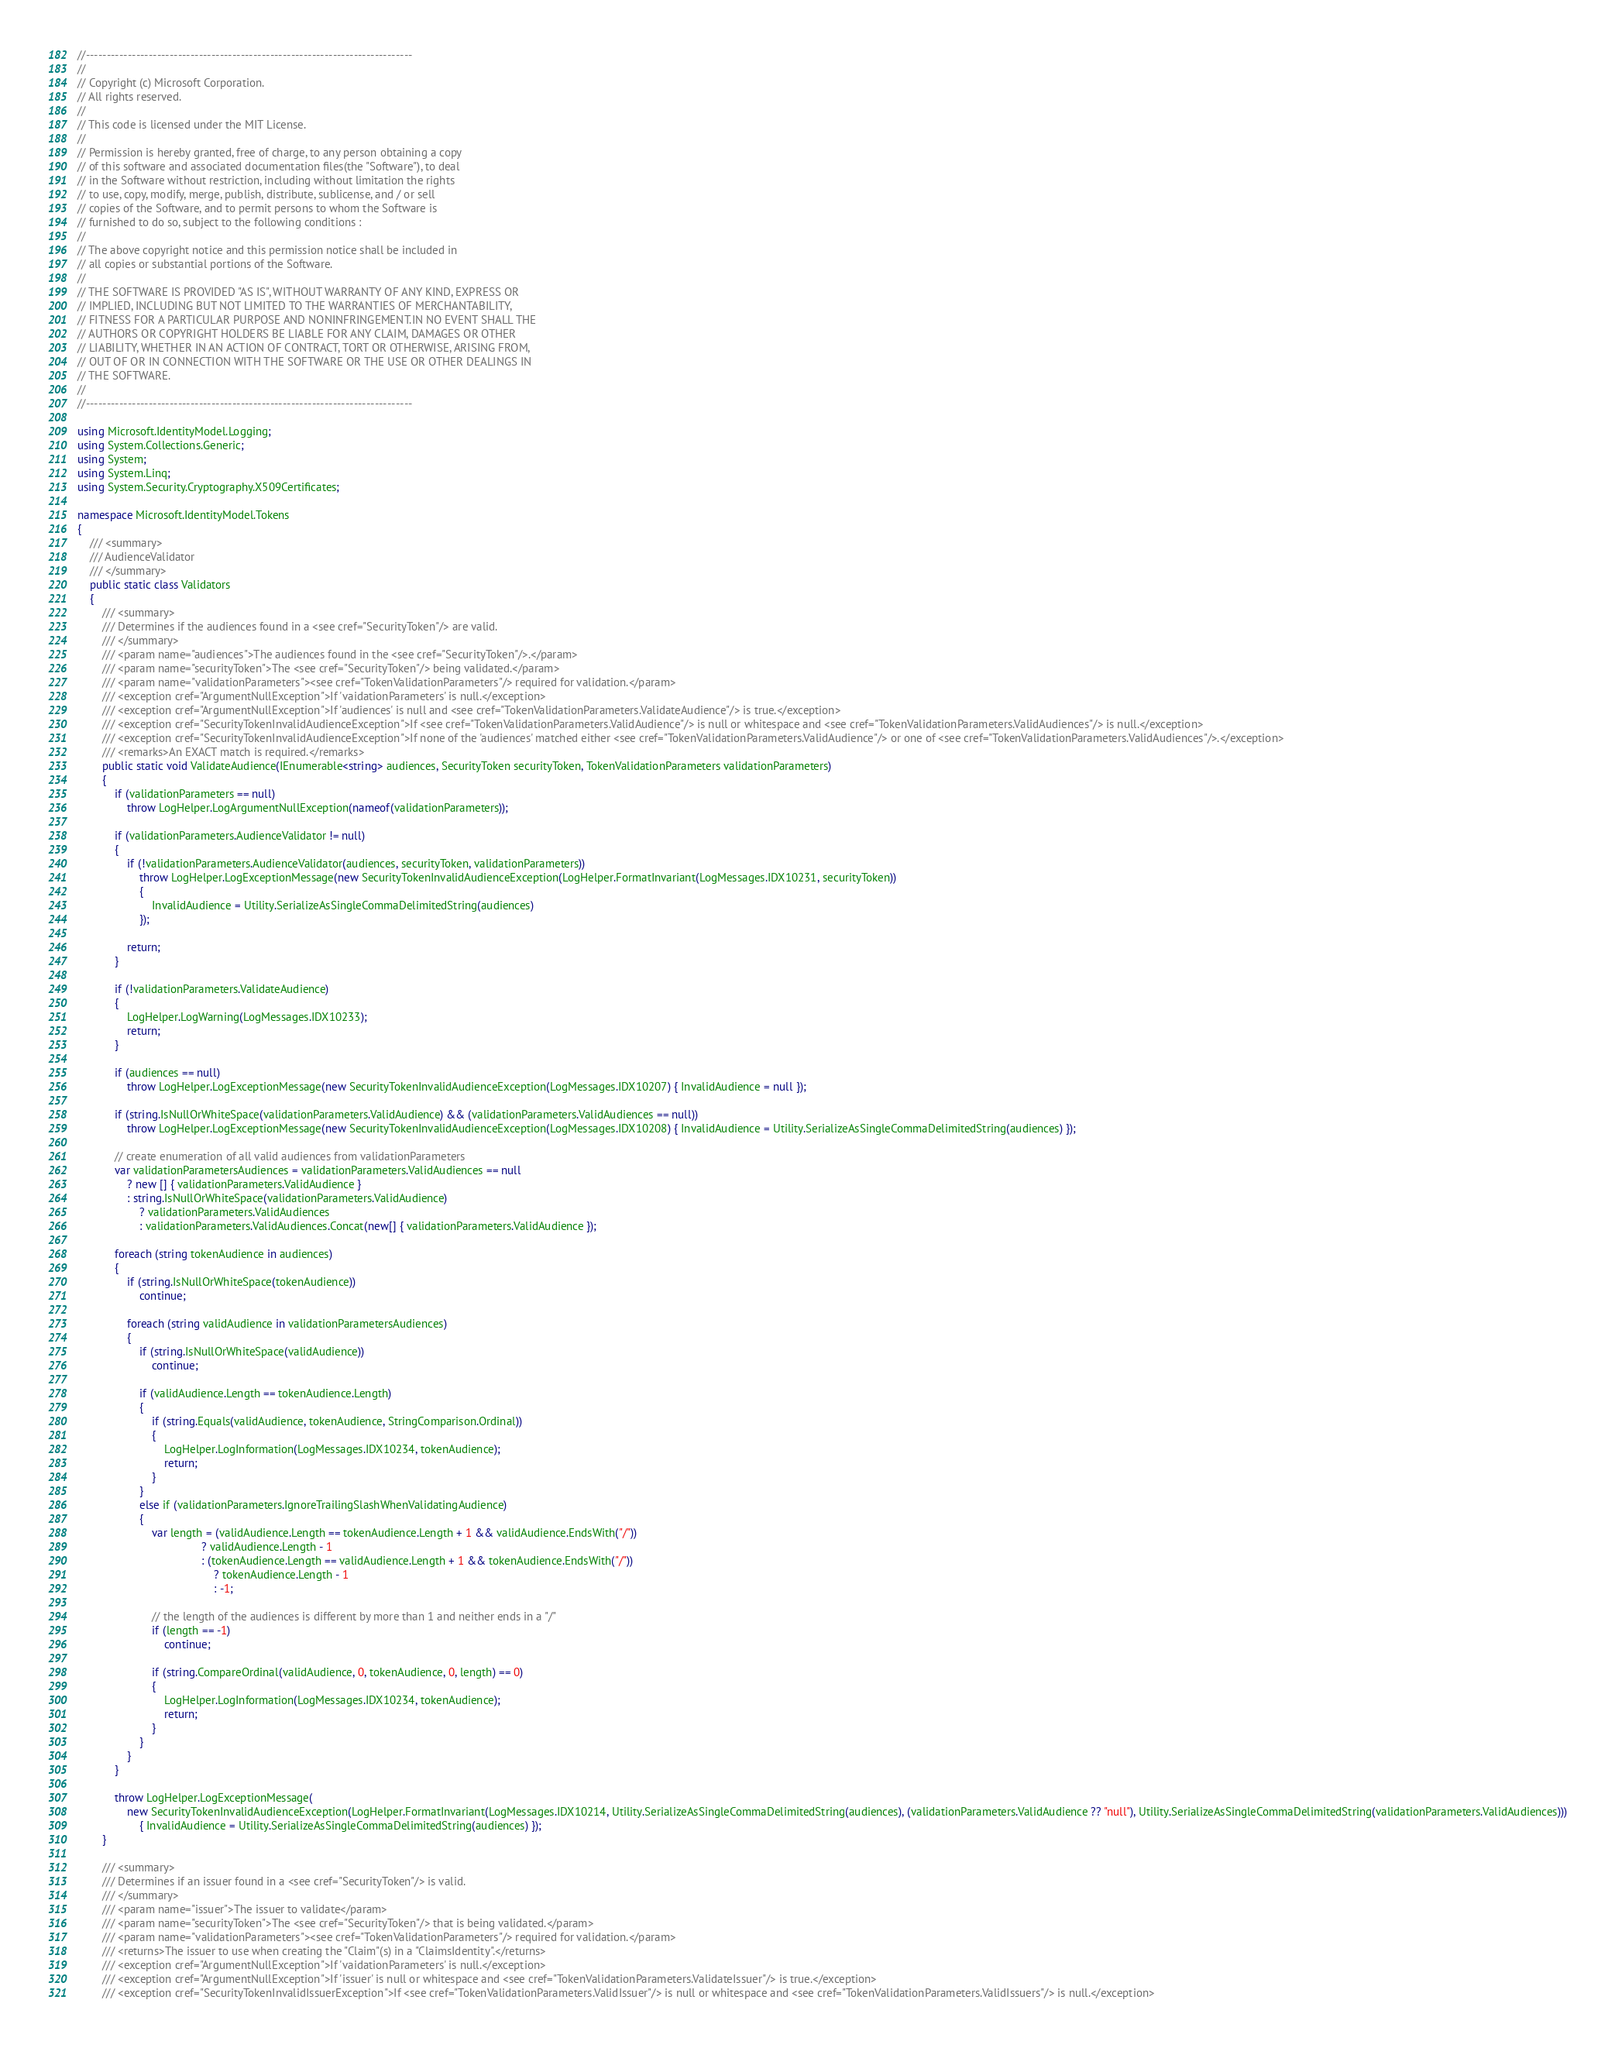<code> <loc_0><loc_0><loc_500><loc_500><_C#_>//------------------------------------------------------------------------------
//
// Copyright (c) Microsoft Corporation.
// All rights reserved.
//
// This code is licensed under the MIT License.
//
// Permission is hereby granted, free of charge, to any person obtaining a copy
// of this software and associated documentation files(the "Software"), to deal
// in the Software without restriction, including without limitation the rights
// to use, copy, modify, merge, publish, distribute, sublicense, and / or sell
// copies of the Software, and to permit persons to whom the Software is
// furnished to do so, subject to the following conditions :
//
// The above copyright notice and this permission notice shall be included in
// all copies or substantial portions of the Software.
//
// THE SOFTWARE IS PROVIDED "AS IS", WITHOUT WARRANTY OF ANY KIND, EXPRESS OR
// IMPLIED, INCLUDING BUT NOT LIMITED TO THE WARRANTIES OF MERCHANTABILITY,
// FITNESS FOR A PARTICULAR PURPOSE AND NONINFRINGEMENT.IN NO EVENT SHALL THE
// AUTHORS OR COPYRIGHT HOLDERS BE LIABLE FOR ANY CLAIM, DAMAGES OR OTHER
// LIABILITY, WHETHER IN AN ACTION OF CONTRACT, TORT OR OTHERWISE, ARISING FROM,
// OUT OF OR IN CONNECTION WITH THE SOFTWARE OR THE USE OR OTHER DEALINGS IN
// THE SOFTWARE.
//
//------------------------------------------------------------------------------

using Microsoft.IdentityModel.Logging;
using System.Collections.Generic;
using System;
using System.Linq;
using System.Security.Cryptography.X509Certificates;

namespace Microsoft.IdentityModel.Tokens
{
    /// <summary>
    /// AudienceValidator
    /// </summary>
    public static class Validators
    {
        /// <summary>
        /// Determines if the audiences found in a <see cref="SecurityToken"/> are valid.
        /// </summary>
        /// <param name="audiences">The audiences found in the <see cref="SecurityToken"/>.</param>
        /// <param name="securityToken">The <see cref="SecurityToken"/> being validated.</param>
        /// <param name="validationParameters"><see cref="TokenValidationParameters"/> required for validation.</param>
        /// <exception cref="ArgumentNullException">If 'vaidationParameters' is null.</exception>
        /// <exception cref="ArgumentNullException">If 'audiences' is null and <see cref="TokenValidationParameters.ValidateAudience"/> is true.</exception>
        /// <exception cref="SecurityTokenInvalidAudienceException">If <see cref="TokenValidationParameters.ValidAudience"/> is null or whitespace and <see cref="TokenValidationParameters.ValidAudiences"/> is null.</exception>
        /// <exception cref="SecurityTokenInvalidAudienceException">If none of the 'audiences' matched either <see cref="TokenValidationParameters.ValidAudience"/> or one of <see cref="TokenValidationParameters.ValidAudiences"/>.</exception>
        /// <remarks>An EXACT match is required.</remarks>
        public static void ValidateAudience(IEnumerable<string> audiences, SecurityToken securityToken, TokenValidationParameters validationParameters)
        {
            if (validationParameters == null)
                throw LogHelper.LogArgumentNullException(nameof(validationParameters));

            if (validationParameters.AudienceValidator != null)
            {
                if (!validationParameters.AudienceValidator(audiences, securityToken, validationParameters))
                    throw LogHelper.LogExceptionMessage(new SecurityTokenInvalidAudienceException(LogHelper.FormatInvariant(LogMessages.IDX10231, securityToken))
                    {
                        InvalidAudience = Utility.SerializeAsSingleCommaDelimitedString(audiences)
                    });

                return;
            }

            if (!validationParameters.ValidateAudience)
            {
                LogHelper.LogWarning(LogMessages.IDX10233);
                return;
            }

            if (audiences == null)
                throw LogHelper.LogExceptionMessage(new SecurityTokenInvalidAudienceException(LogMessages.IDX10207) { InvalidAudience = null });

            if (string.IsNullOrWhiteSpace(validationParameters.ValidAudience) && (validationParameters.ValidAudiences == null))
                throw LogHelper.LogExceptionMessage(new SecurityTokenInvalidAudienceException(LogMessages.IDX10208) { InvalidAudience = Utility.SerializeAsSingleCommaDelimitedString(audiences) });

            // create enumeration of all valid audiences from validationParameters
            var validationParametersAudiences = validationParameters.ValidAudiences == null
                ? new [] { validationParameters.ValidAudience }
                : string.IsNullOrWhiteSpace(validationParameters.ValidAudience)
                    ? validationParameters.ValidAudiences
                    : validationParameters.ValidAudiences.Concat(new[] { validationParameters.ValidAudience });

            foreach (string tokenAudience in audiences)
            {
                if (string.IsNullOrWhiteSpace(tokenAudience))
                    continue;

                foreach (string validAudience in validationParametersAudiences)
                {
                    if (string.IsNullOrWhiteSpace(validAudience))
                        continue;

                    if (validAudience.Length == tokenAudience.Length)
                    {
                        if (string.Equals(validAudience, tokenAudience, StringComparison.Ordinal))
                        {
                            LogHelper.LogInformation(LogMessages.IDX10234, tokenAudience);
                            return;
                        }
                    }
                    else if (validationParameters.IgnoreTrailingSlashWhenValidatingAudience)
                    {
                        var length = (validAudience.Length == tokenAudience.Length + 1 && validAudience.EndsWith("/"))
                                        ? validAudience.Length - 1
                                        : (tokenAudience.Length == validAudience.Length + 1 && tokenAudience.EndsWith("/"))
                                            ? tokenAudience.Length - 1
                                            : -1;

                        // the length of the audiences is different by more than 1 and neither ends in a "/"
                        if (length == -1)
                            continue;

                        if (string.CompareOrdinal(validAudience, 0, tokenAudience, 0, length) == 0)
                        {
                            LogHelper.LogInformation(LogMessages.IDX10234, tokenAudience);
                            return;
                        }
                    }
                }
            }

            throw LogHelper.LogExceptionMessage(
                new SecurityTokenInvalidAudienceException(LogHelper.FormatInvariant(LogMessages.IDX10214, Utility.SerializeAsSingleCommaDelimitedString(audiences), (validationParameters.ValidAudience ?? "null"), Utility.SerializeAsSingleCommaDelimitedString(validationParameters.ValidAudiences)))
                    { InvalidAudience = Utility.SerializeAsSingleCommaDelimitedString(audiences) });
        }
    
        /// <summary>
        /// Determines if an issuer found in a <see cref="SecurityToken"/> is valid.
        /// </summary>
        /// <param name="issuer">The issuer to validate</param>
        /// <param name="securityToken">The <see cref="SecurityToken"/> that is being validated.</param>
        /// <param name="validationParameters"><see cref="TokenValidationParameters"/> required for validation.</param>
        /// <returns>The issuer to use when creating the "Claim"(s) in a "ClaimsIdentity".</returns>
        /// <exception cref="ArgumentNullException">If 'vaidationParameters' is null.</exception>
        /// <exception cref="ArgumentNullException">If 'issuer' is null or whitespace and <see cref="TokenValidationParameters.ValidateIssuer"/> is true.</exception>
        /// <exception cref="SecurityTokenInvalidIssuerException">If <see cref="TokenValidationParameters.ValidIssuer"/> is null or whitespace and <see cref="TokenValidationParameters.ValidIssuers"/> is null.</exception></code> 